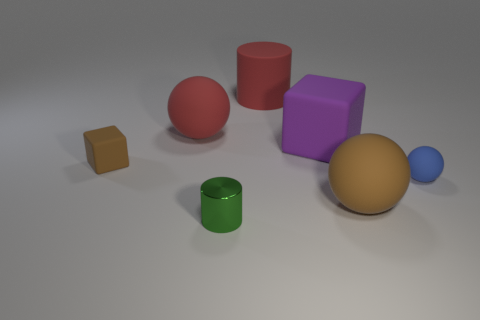Add 1 rubber things. How many objects exist? 8 Subtract all spheres. How many objects are left? 4 Add 4 large red rubber balls. How many large red rubber balls are left? 5 Add 6 small green cylinders. How many small green cylinders exist? 7 Subtract 0 cyan cylinders. How many objects are left? 7 Subtract all small cyan rubber cylinders. Subtract all red rubber objects. How many objects are left? 5 